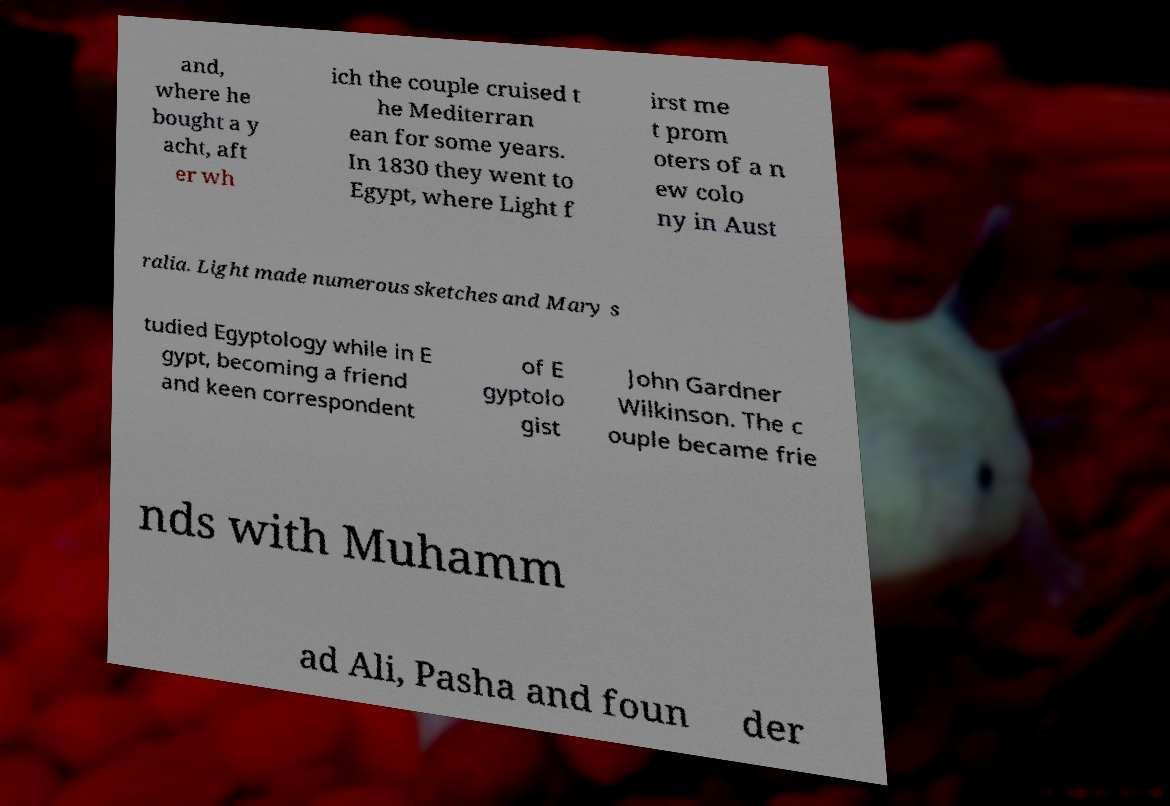Can you accurately transcribe the text from the provided image for me? and, where he bought a y acht, aft er wh ich the couple cruised t he Mediterran ean for some years. In 1830 they went to Egypt, where Light f irst me t prom oters of a n ew colo ny in Aust ralia. Light made numerous sketches and Mary s tudied Egyptology while in E gypt, becoming a friend and keen correspondent of E gyptolo gist John Gardner Wilkinson. The c ouple became frie nds with Muhamm ad Ali, Pasha and foun der 